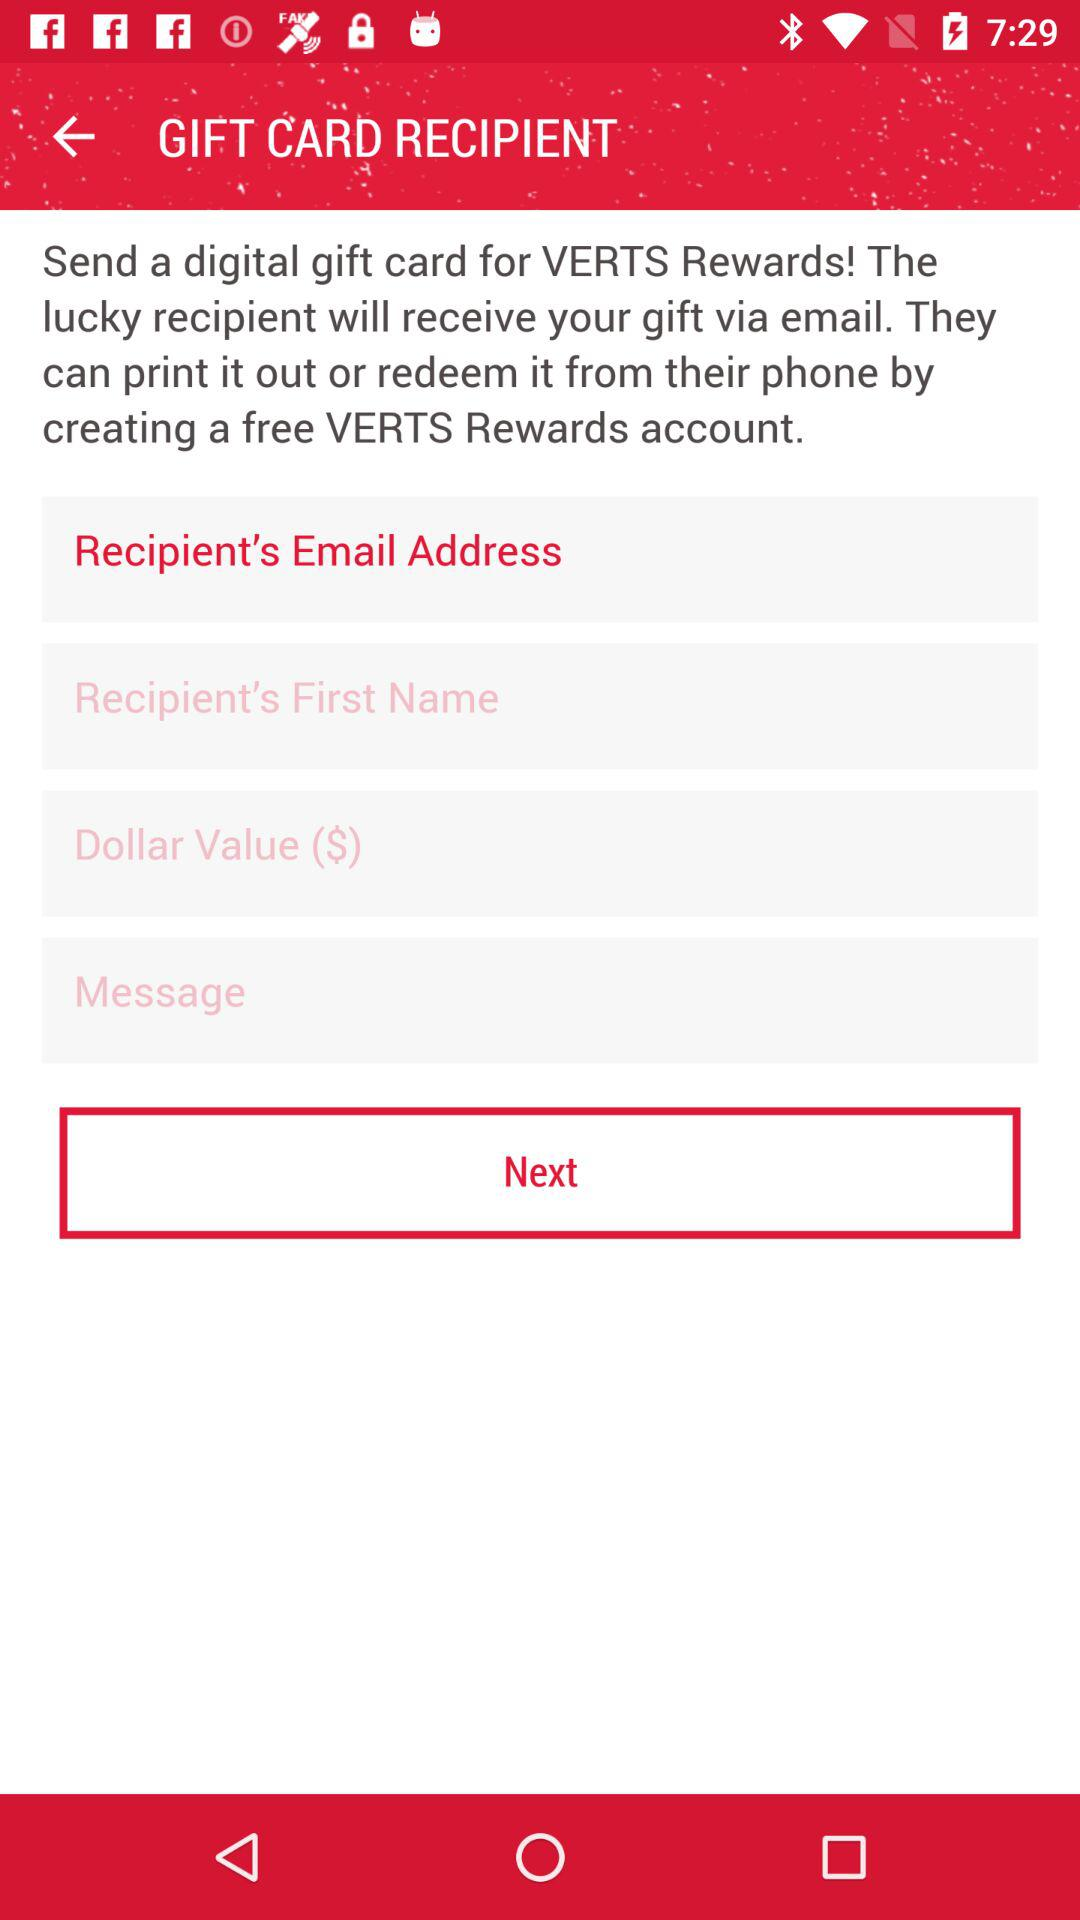Which option is selected? The selected option is "Recipient's Email Address". 